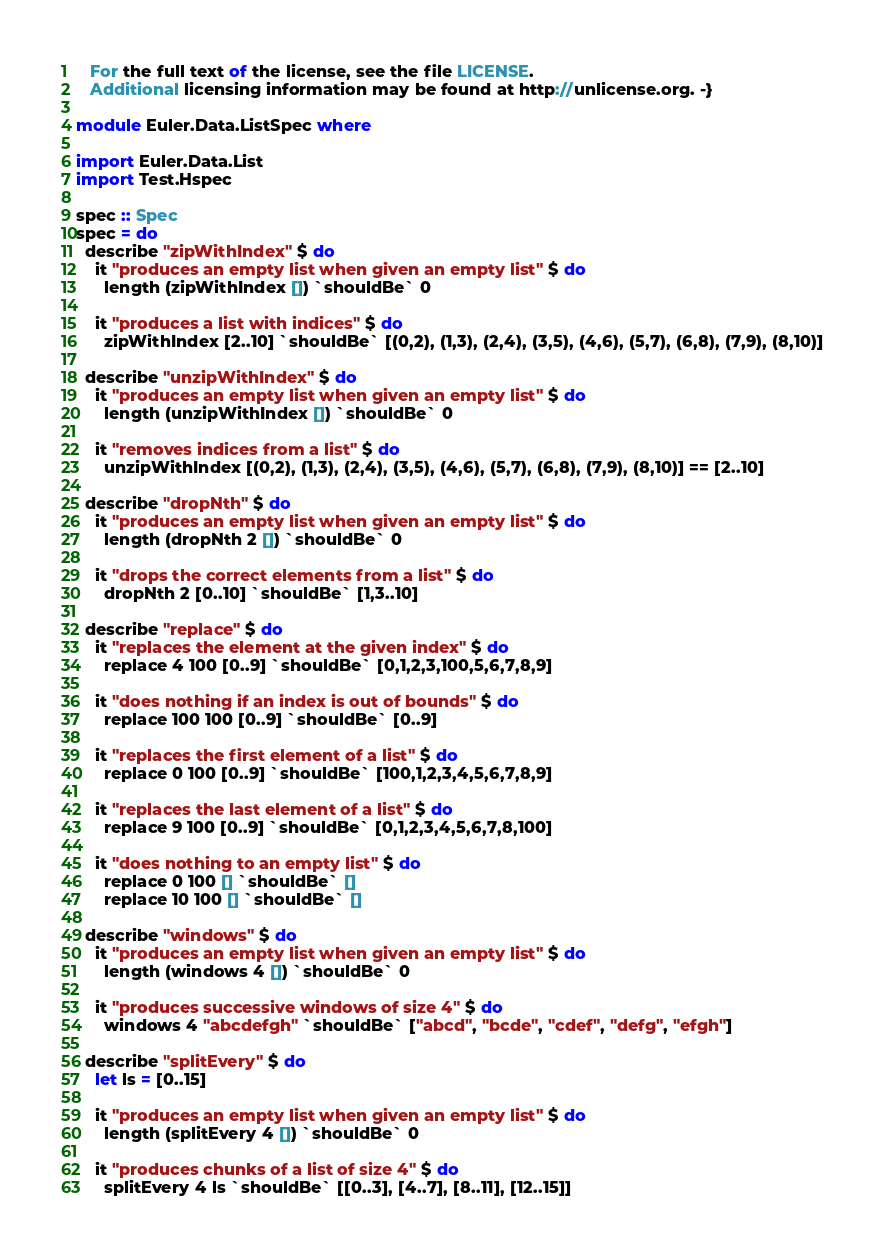Convert code to text. <code><loc_0><loc_0><loc_500><loc_500><_Haskell_>   For the full text of the license, see the file LICENSE.
   Additional licensing information may be found at http://unlicense.org. -}

module Euler.Data.ListSpec where

import Euler.Data.List
import Test.Hspec

spec :: Spec
spec = do
  describe "zipWithIndex" $ do
    it "produces an empty list when given an empty list" $ do
      length (zipWithIndex []) `shouldBe` 0

    it "produces a list with indices" $ do
      zipWithIndex [2..10] `shouldBe` [(0,2), (1,3), (2,4), (3,5), (4,6), (5,7), (6,8), (7,9), (8,10)]

  describe "unzipWithIndex" $ do
    it "produces an empty list when given an empty list" $ do
      length (unzipWithIndex []) `shouldBe` 0

    it "removes indices from a list" $ do
      unzipWithIndex [(0,2), (1,3), (2,4), (3,5), (4,6), (5,7), (6,8), (7,9), (8,10)] == [2..10]

  describe "dropNth" $ do
    it "produces an empty list when given an empty list" $ do
      length (dropNth 2 []) `shouldBe` 0

    it "drops the correct elements from a list" $ do
      dropNth 2 [0..10] `shouldBe` [1,3..10]

  describe "replace" $ do
    it "replaces the element at the given index" $ do
      replace 4 100 [0..9] `shouldBe` [0,1,2,3,100,5,6,7,8,9]

    it "does nothing if an index is out of bounds" $ do
      replace 100 100 [0..9] `shouldBe` [0..9]

    it "replaces the first element of a list" $ do
      replace 0 100 [0..9] `shouldBe` [100,1,2,3,4,5,6,7,8,9]

    it "replaces the last element of a list" $ do
      replace 9 100 [0..9] `shouldBe` [0,1,2,3,4,5,6,7,8,100]

    it "does nothing to an empty list" $ do
      replace 0 100 [] `shouldBe` []
      replace 10 100 [] `shouldBe` []

  describe "windows" $ do
    it "produces an empty list when given an empty list" $ do
      length (windows 4 []) `shouldBe` 0

    it "produces successive windows of size 4" $ do
      windows 4 "abcdefgh" `shouldBe` ["abcd", "bcde", "cdef", "defg", "efgh"]

  describe "splitEvery" $ do
    let ls = [0..15]

    it "produces an empty list when given an empty list" $ do
      length (splitEvery 4 []) `shouldBe` 0

    it "produces chunks of a list of size 4" $ do
      splitEvery 4 ls `shouldBe` [[0..3], [4..7], [8..11], [12..15]]
</code> 